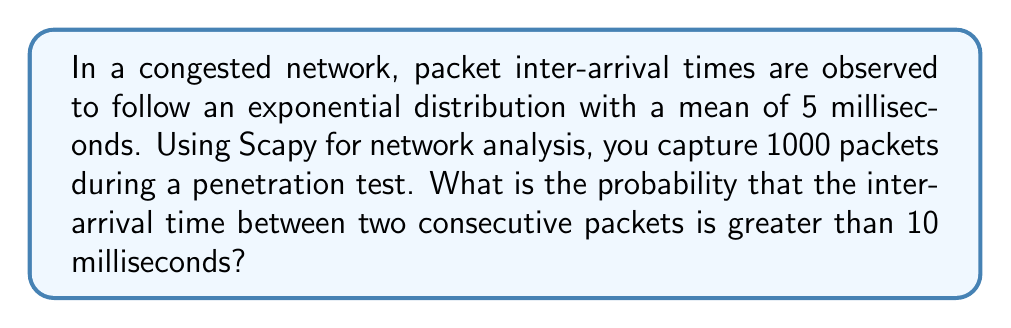Give your solution to this math problem. Let's approach this step-by-step:

1) The inter-arrival times follow an exponential distribution with mean $\mu = 5$ ms.

2) For an exponential distribution, the rate parameter $\lambda$ is the inverse of the mean:

   $\lambda = \frac{1}{\mu} = \frac{1}{5} = 0.2$ ms^(-1)

3) The probability density function (PDF) of an exponential distribution is:

   $f(x) = \lambda e^{-\lambda x}$ for $x \geq 0$

4) We want to find $P(X > 10)$, where $X$ is the inter-arrival time.

5) For an exponential distribution, $P(X > x) = e^{-\lambda x}$

6) Substituting our values:

   $P(X > 10) = e^{-0.2 * 10} = e^{-2}$

7) Using a calculator or computer:

   $e^{-2} \approx 0.1353$

Therefore, the probability that the inter-arrival time between two consecutive packets is greater than 10 milliseconds is approximately 0.1353 or 13.53%.
Answer: $e^{-2} \approx 0.1353$ or 13.53% 